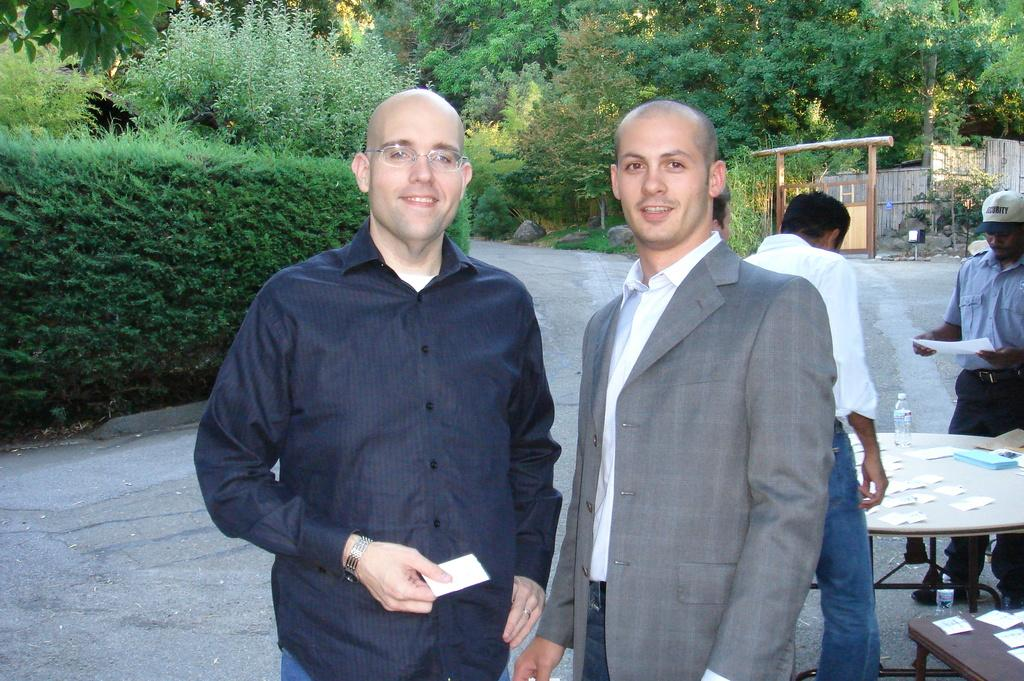What are the two persons in the foreground of the image doing? The two persons in the foreground are standing and holding a card. Can you describe the people in the background of the image? There are two other persons standing in the background. What type of furniture is visible in the image? There is a round table in the image. What architectural feature can be seen in the image? There is a wooden gate in the image. What type of natural elements are present in the image? Trees and plants are present in the image. What type of toys can be seen on the window sill in the image? There is no window or window sill present in the image, and therefore no toys can be seen. 